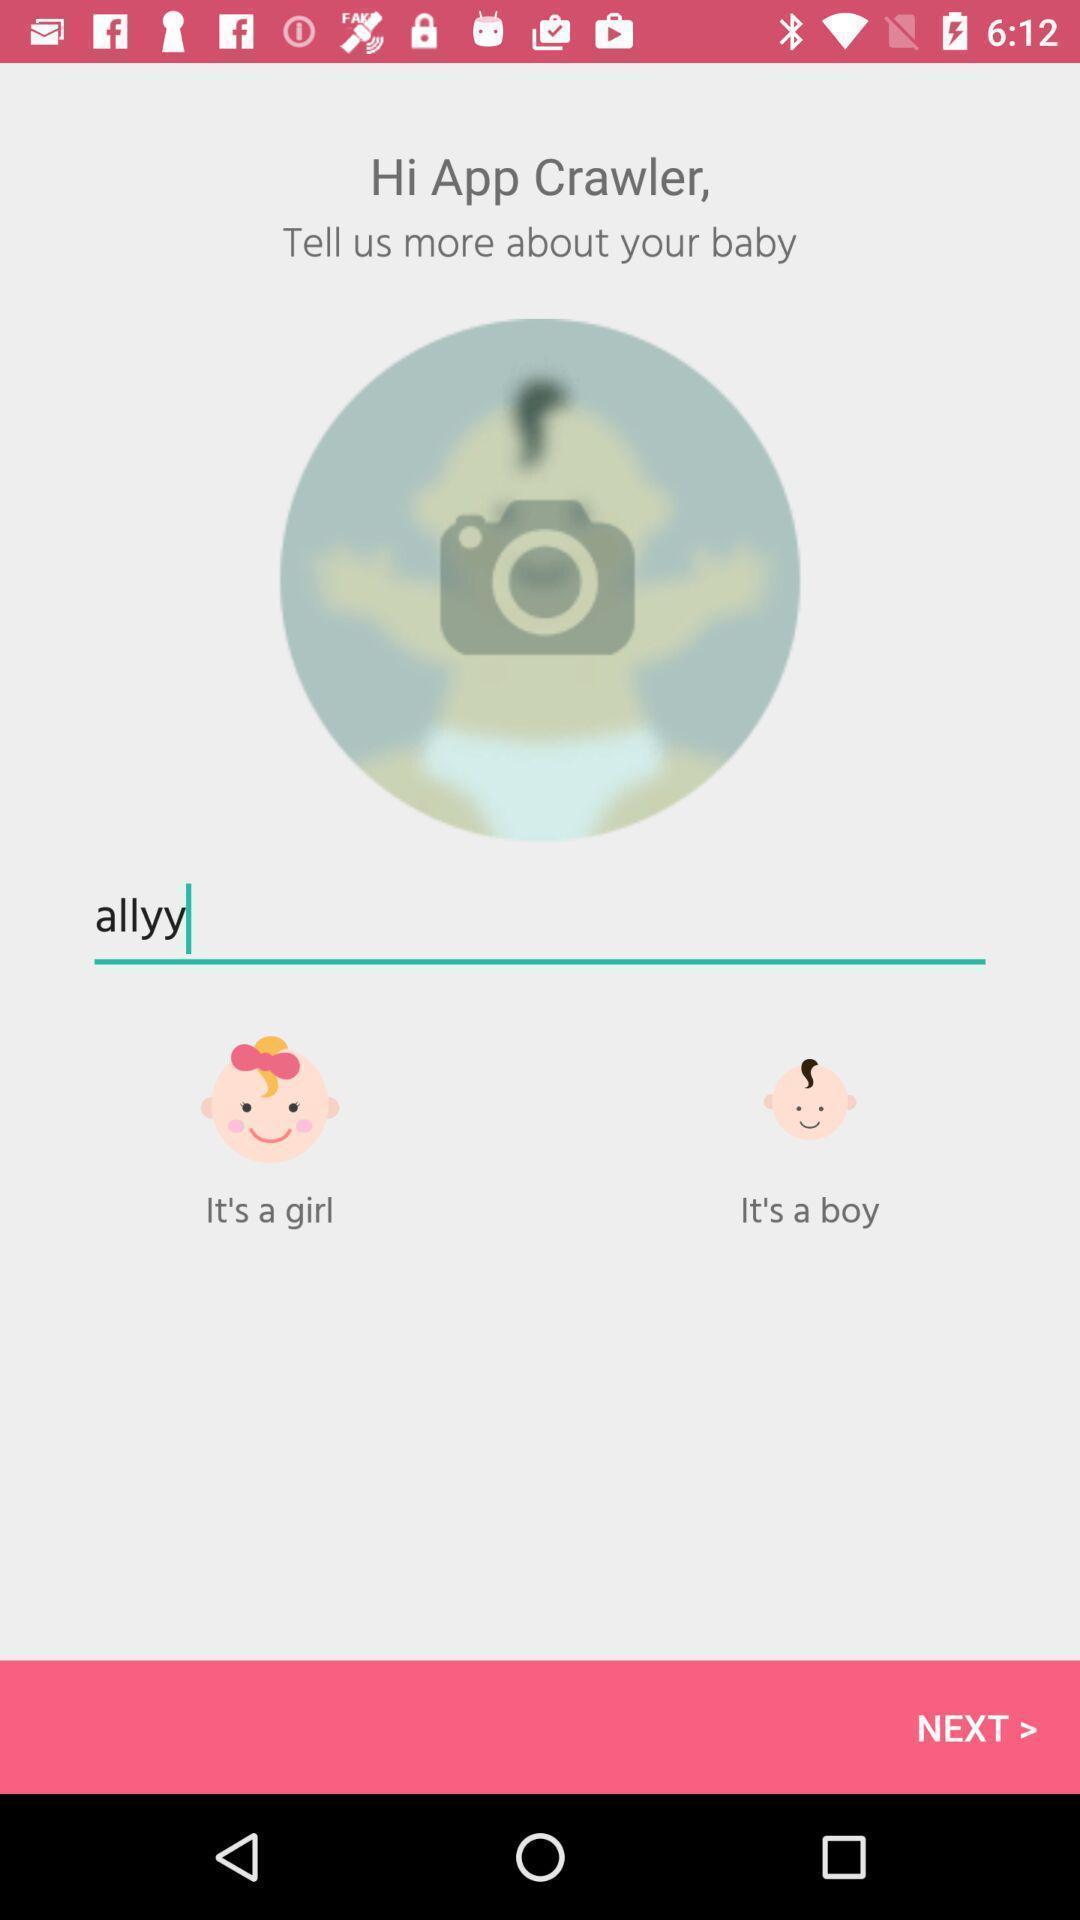Tell me about the visual elements in this screen capture. Select a image of a new profile. 